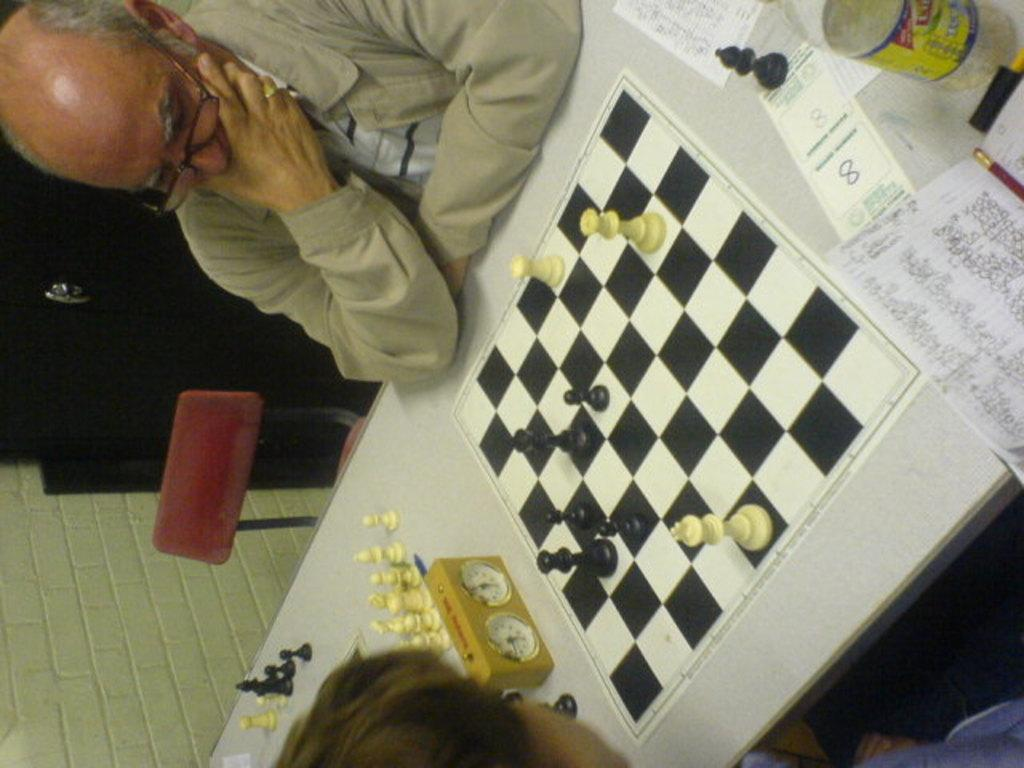What are the people in the image doing? The persons sitting at the table are likely engaged in some activity, but the specifics are not clear from the facts provided. What object on the table can be used to measure time? There is a stopwatch on the table. What type of game is being played or set up on the table? There is a chess board on the table. What else is present on the table besides the chess board? Papers and a bottle are also present on the table. What can be seen in the background of the image? There is a chair, a cupboard, and a wall in the background. What letter is being written by the person sitting at the table? There is no mention of a letter or any writing activity in the image. How many boys are present in the image? The facts provided do not specify the gender or number of persons sitting at the table. 